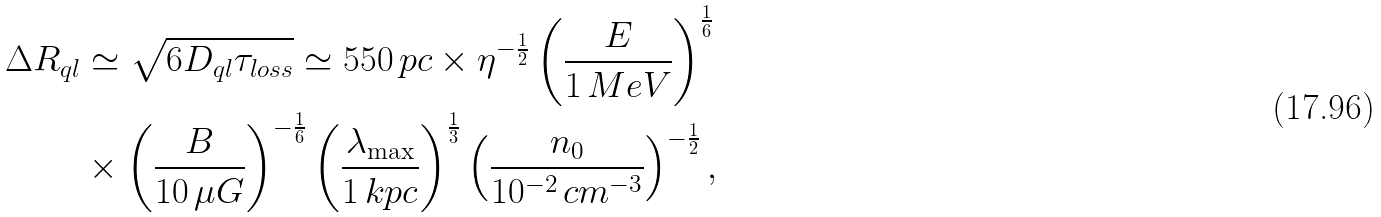<formula> <loc_0><loc_0><loc_500><loc_500>\Delta R _ { q l } & \simeq \sqrt { 6 D _ { q l } \tau _ { l o s s } } \simeq 5 5 0 \, p c \times \eta ^ { - \frac { 1 } { 2 } } \left ( \frac { E } { 1 \, M e V } \right ) ^ { \frac { 1 } { 6 } } \\ & \times \left ( \frac { B } { 1 0 \, \mu G } \right ) ^ { - \frac { 1 } { 6 } } \left ( \frac { \lambda _ { \max } } { 1 \, k p c } \right ) ^ { \frac { 1 } { 3 } } \left ( \frac { n _ { 0 } } { 1 0 ^ { - 2 } \, c m ^ { - 3 } } \right ) ^ { - \frac { 1 } { 2 } } ,</formula> 